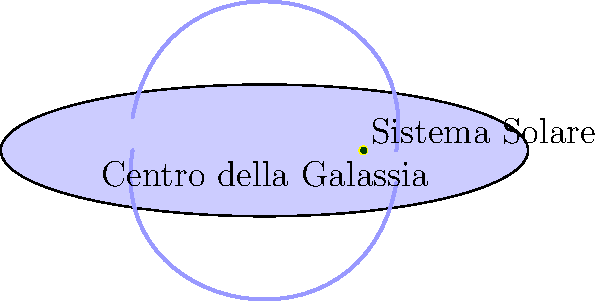Nella rappresentazione della nostra galassia, la Via Lattea, dove si trova la Terra rispetto al centro galattico? Per comprendere la posizione della Terra nella Via Lattea, seguiamo questi passaggi:

1. Osserviamo che la Via Lattea è rappresentata come un disco ellittico, che rappresenta la sua forma a spirale vista dall'alto.

2. Il centro della galassia è chiaramente indicato al centro dell'ellisse.

3. Notiamo due linee curve che rappresentano i bracci a spirale della galassia.

4. Il Sistema Solare, che include la Terra, è rappresentato da due punti vicini: uno giallo più grande (il Sole) e uno verde più piccolo accanto ad esso (la Terra).

5. Osserviamo che il Sistema Solare non si trova al centro della galassia, ma è posizionato a circa un terzo della distanza tra il centro e il bordo del disco galattico.

6. Questa posizione corrisponde a circa 26.000 anni luce dal centro galattico, in una regione conosciuta come "Braccio di Orione" o "Sperone di Orione".

7. La Terra, essendo parte del Sistema Solare, si trova quindi in questa posizione intermedia, né al centro né al bordo della galassia.

Questa rappresentazione ci aiuta a comprendere che la Terra occupa una posizione "periferica" nella Via Lattea, ricordandoci l'immensità della nostra galassia e l'umiltà della nostra posizione nell'universo, un concetto che si allinea bene con gli insegnamenti della Chiesa sulla creazione divina.
Answer: In una posizione intermedia, a circa un terzo della distanza tra il centro e il bordo della galassia. 